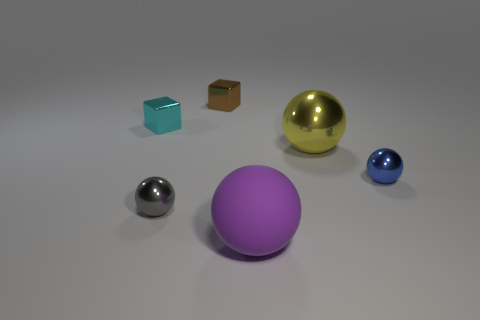What could be the purpose of these objects being together? They could be part of a decorative set, designed to be visually appealing through their varied shapes, sizes, and materials. Alternatively, they might be educational tools, used to demonstrate properties like reflection, texture, and geometry, or simply elements in a larger art installation without a specific functional purpose beyond aesthetics. 